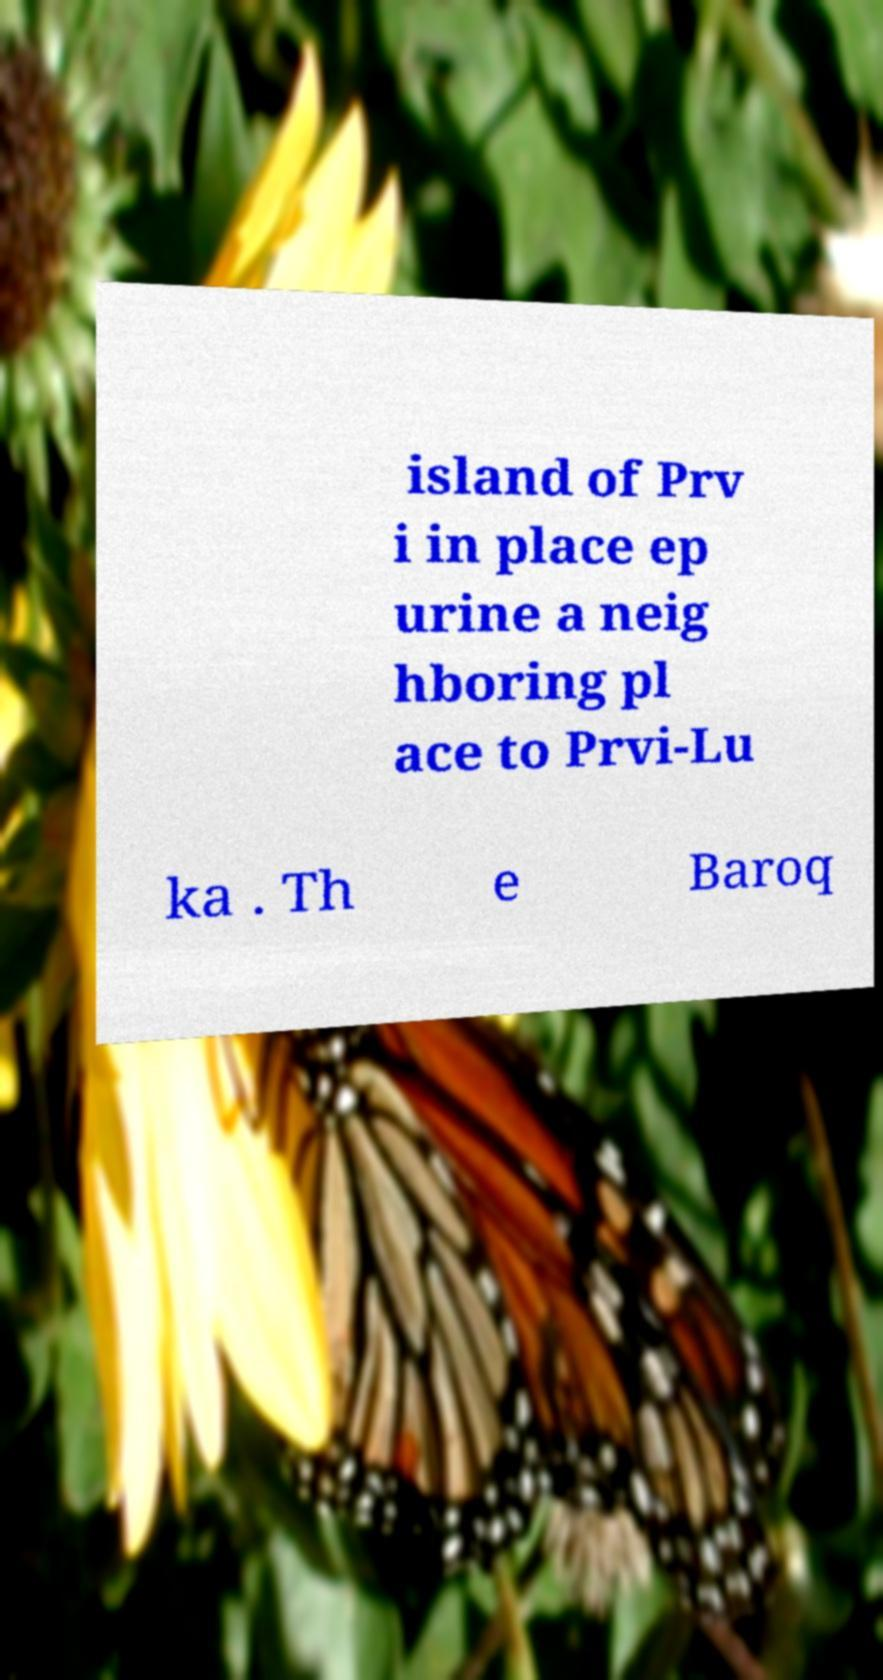Can you accurately transcribe the text from the provided image for me? island of Prv i in place ep urine a neig hboring pl ace to Prvi-Lu ka . Th e Baroq 